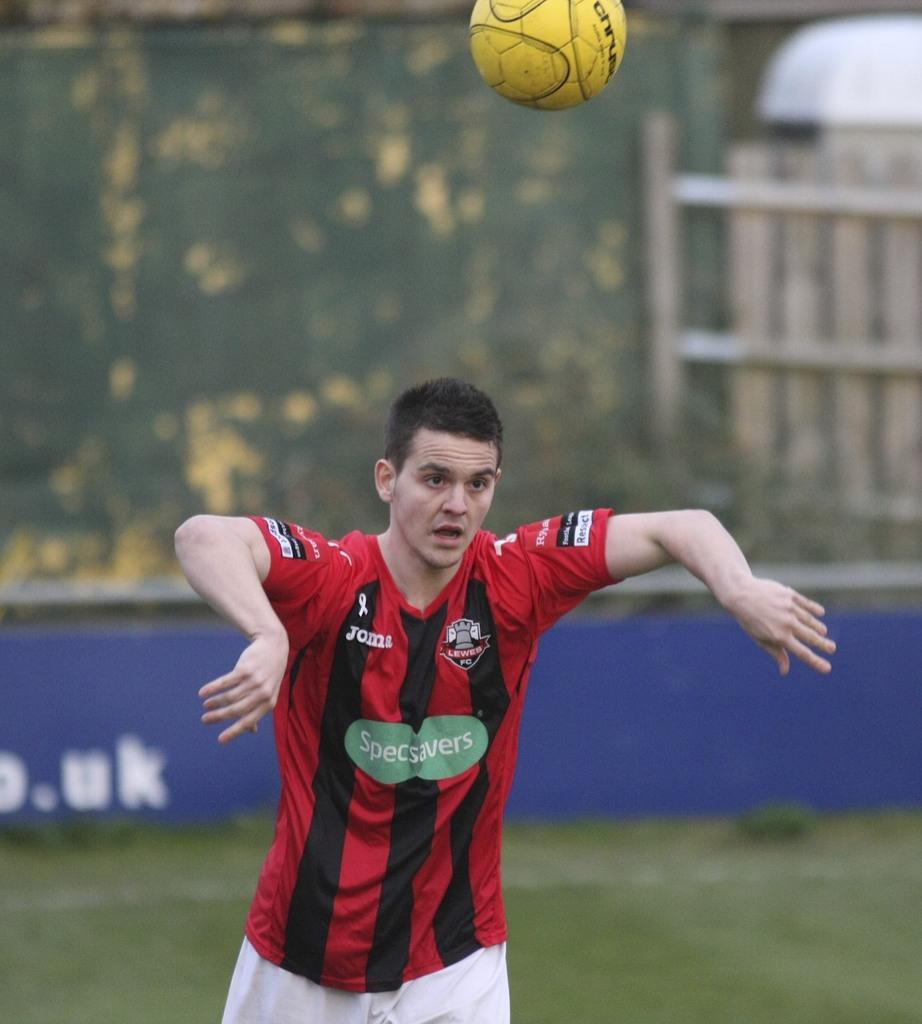<image>
Render a clear and concise summary of the photo. A player wearing a specsavers sponsored jersey bounces a ball off his head 